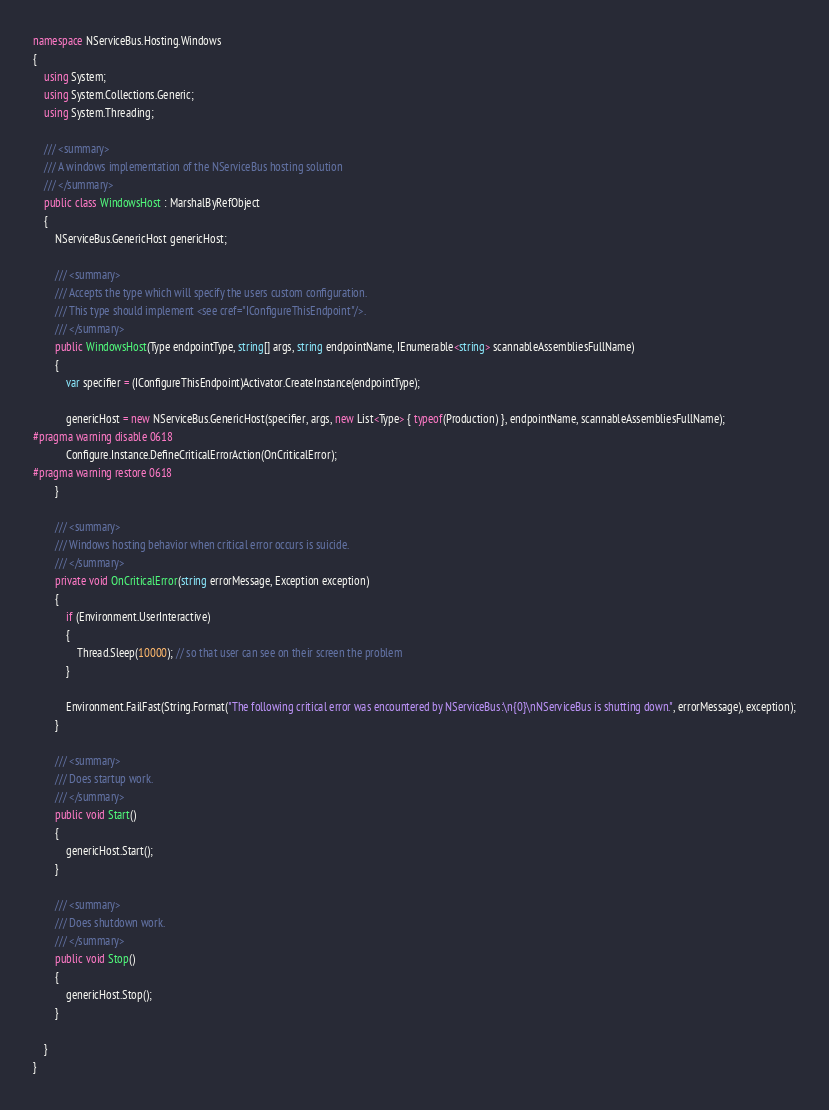Convert code to text. <code><loc_0><loc_0><loc_500><loc_500><_C#_>namespace NServiceBus.Hosting.Windows
{
    using System;
    using System.Collections.Generic;
    using System.Threading;

    /// <summary>
    /// A windows implementation of the NServiceBus hosting solution
    /// </summary>
    public class WindowsHost : MarshalByRefObject
    {
        NServiceBus.GenericHost genericHost;

        /// <summary>
        /// Accepts the type which will specify the users custom configuration.
        /// This type should implement <see cref="IConfigureThisEndpoint"/>.
        /// </summary>
        public WindowsHost(Type endpointType, string[] args, string endpointName, IEnumerable<string> scannableAssembliesFullName)
        {
            var specifier = (IConfigureThisEndpoint)Activator.CreateInstance(endpointType);

            genericHost = new NServiceBus.GenericHost(specifier, args, new List<Type> { typeof(Production) }, endpointName, scannableAssembliesFullName);
#pragma warning disable 0618
            Configure.Instance.DefineCriticalErrorAction(OnCriticalError);
#pragma warning restore 0618
        }

        /// <summary>
        /// Windows hosting behavior when critical error occurs is suicide.
        /// </summary>
        private void OnCriticalError(string errorMessage, Exception exception)
        {
            if (Environment.UserInteractive)
            {
                Thread.Sleep(10000); // so that user can see on their screen the problem
            }
            
            Environment.FailFast(String.Format("The following critical error was encountered by NServiceBus:\n{0}\nNServiceBus is shutting down.", errorMessage), exception);
        }

        /// <summary>
        /// Does startup work.
        /// </summary>
        public void Start()
        {
            genericHost.Start();
        }

        /// <summary>
        /// Does shutdown work.
        /// </summary>
        public void Stop()
        {
            genericHost.Stop();
        }

    }
}</code> 